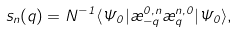<formula> <loc_0><loc_0><loc_500><loc_500>s _ { n } ( q ) = N ^ { - 1 } \langle \Psi _ { 0 } | \rho _ { - q } ^ { 0 , n } \rho _ { q } ^ { n , 0 } | \Psi _ { 0 } \rangle ,</formula> 